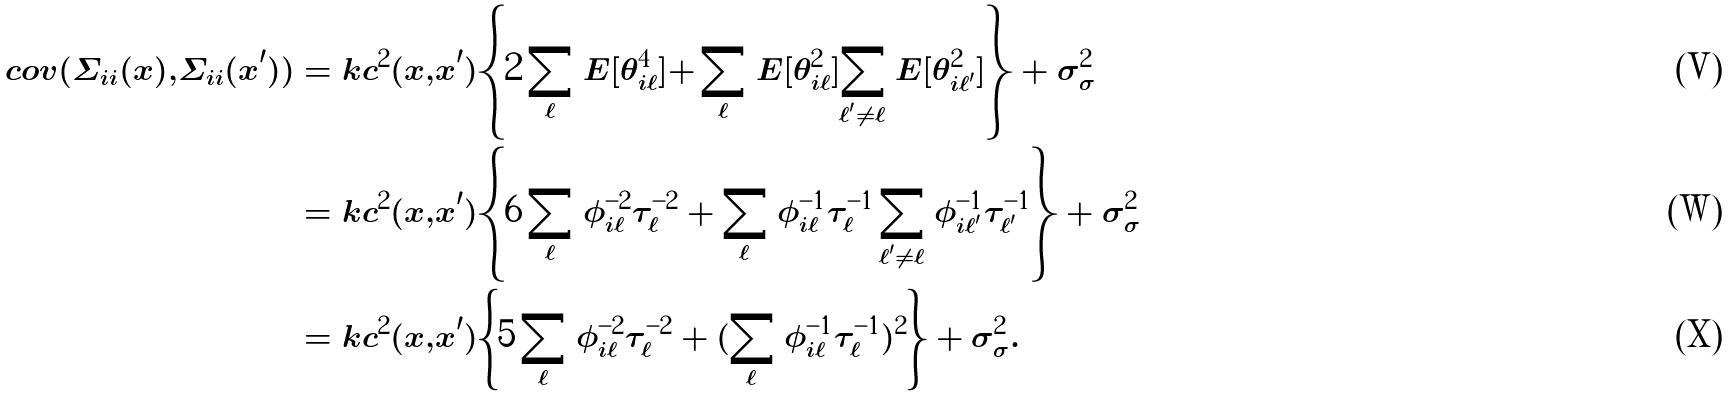<formula> <loc_0><loc_0><loc_500><loc_500>c o v ( \Sigma _ { i i } ( x ) , \Sigma _ { i i } ( x ^ { \prime } ) ) & = k c ^ { 2 } ( x , x ^ { \prime } ) \left \{ 2 \sum _ { \ell } E [ \theta ^ { 4 } _ { i \ell } ] + \sum _ { \ell } E [ \theta ^ { 2 } _ { i \ell } ] \sum _ { \ell ^ { \prime } \neq \ell } E [ \theta ^ { 2 } _ { i \ell ^ { \prime } } ] \right \} + \sigma _ { \sigma } ^ { 2 } \\ & = k c ^ { 2 } ( x , x ^ { \prime } ) \left \{ 6 \sum _ { \ell } \phi _ { i \ell } ^ { - 2 } \tau _ { \ell } ^ { - 2 } + \sum _ { \ell } \phi _ { i \ell } ^ { - 1 } \tau _ { \ell } ^ { - 1 } \sum _ { \ell ^ { \prime } \neq \ell } \phi _ { i \ell ^ { \prime } } ^ { - 1 } \tau _ { \ell ^ { \prime } } ^ { - 1 } \right \} + \sigma _ { \sigma } ^ { 2 } \\ & = k c ^ { 2 } ( x , x ^ { \prime } ) \left \{ 5 \sum _ { \ell } \phi _ { i \ell } ^ { - 2 } \tau _ { \ell } ^ { - 2 } + ( \sum _ { \ell } \phi _ { i \ell } ^ { - 1 } \tau _ { \ell } ^ { - 1 } ) ^ { 2 } \right \} + \sigma _ { \sigma } ^ { 2 } .</formula> 